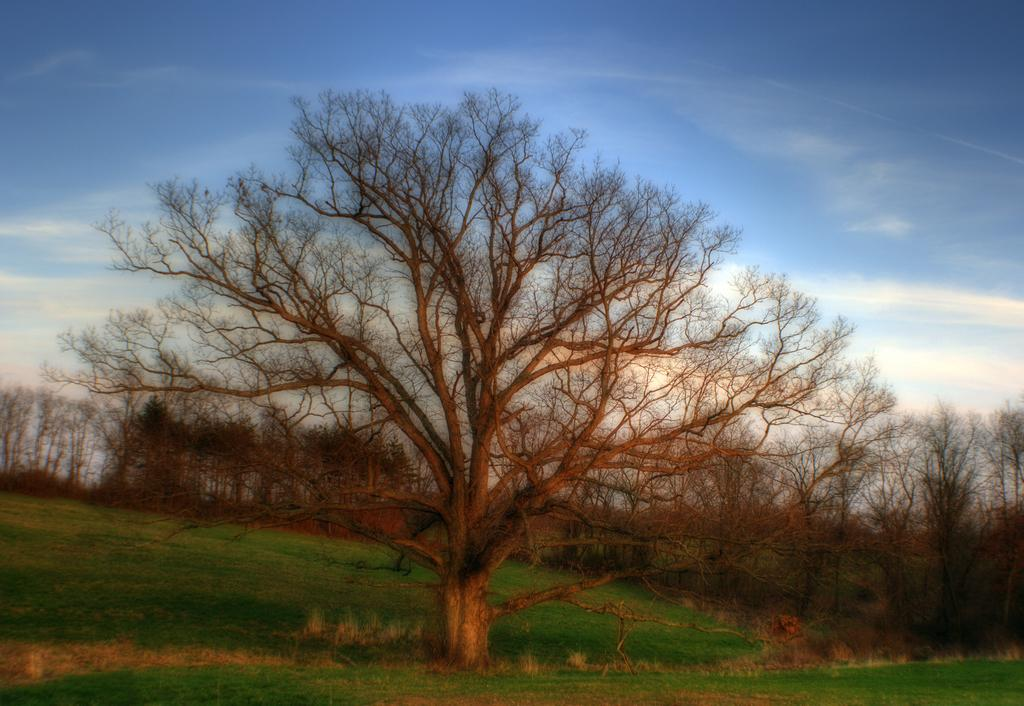What type of landscape is depicted in the image? There is a grassland in the image. What can be seen in the distance in the image? There are trees in the background of the image. What is visible above the grassland and trees in the image? The sky is visible in the background of the image. What type of fork is being used by the minister in the image? There is no minister or fork present in the image. 